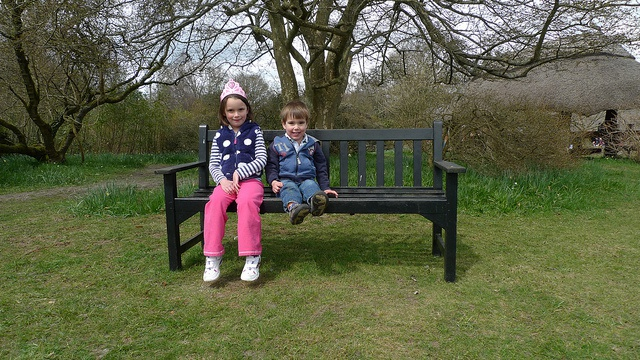Describe the objects in this image and their specific colors. I can see bench in darkgray, black, gray, and darkgreen tones, people in darkgray, violet, white, navy, and black tones, and people in darkgray, black, gray, and navy tones in this image. 